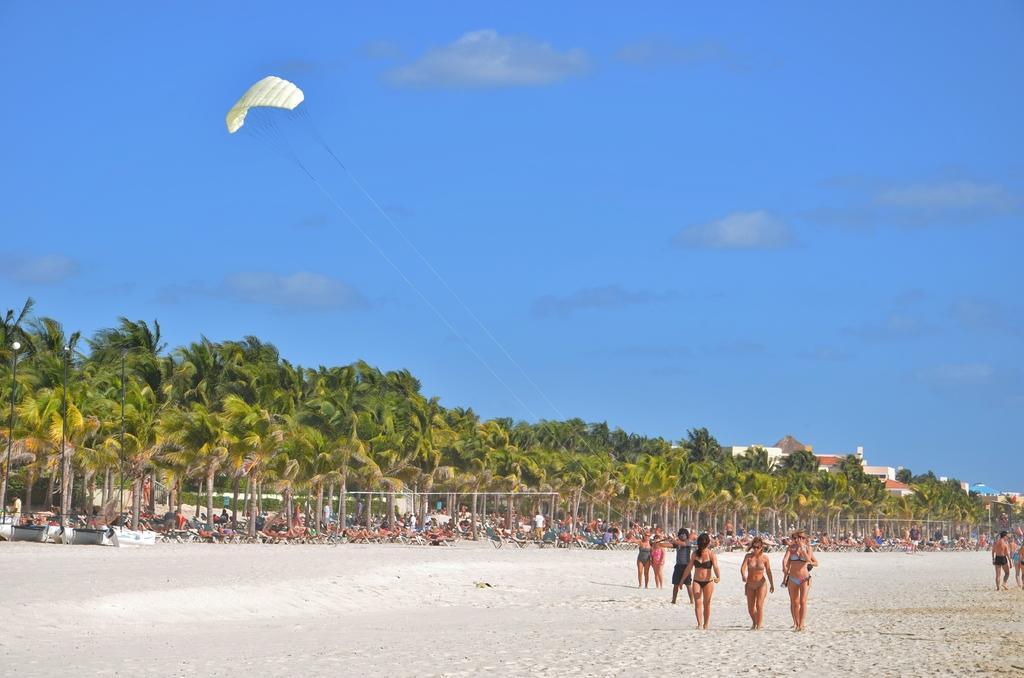In one or two sentences, can you explain what this image depicts? In the image we can see there are people standing near the sea beach and others are sitting on the chair. There are lot of trees and behind there is a building. 